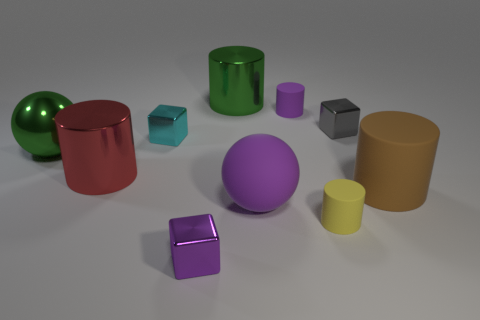Is the color of the rubber sphere the same as the metal ball? The rubber sphere and the metal ball have distinct color appearances. Due to differences in material properties, like light reflection and texture, their colors may seem different under the same lighting conditions. 